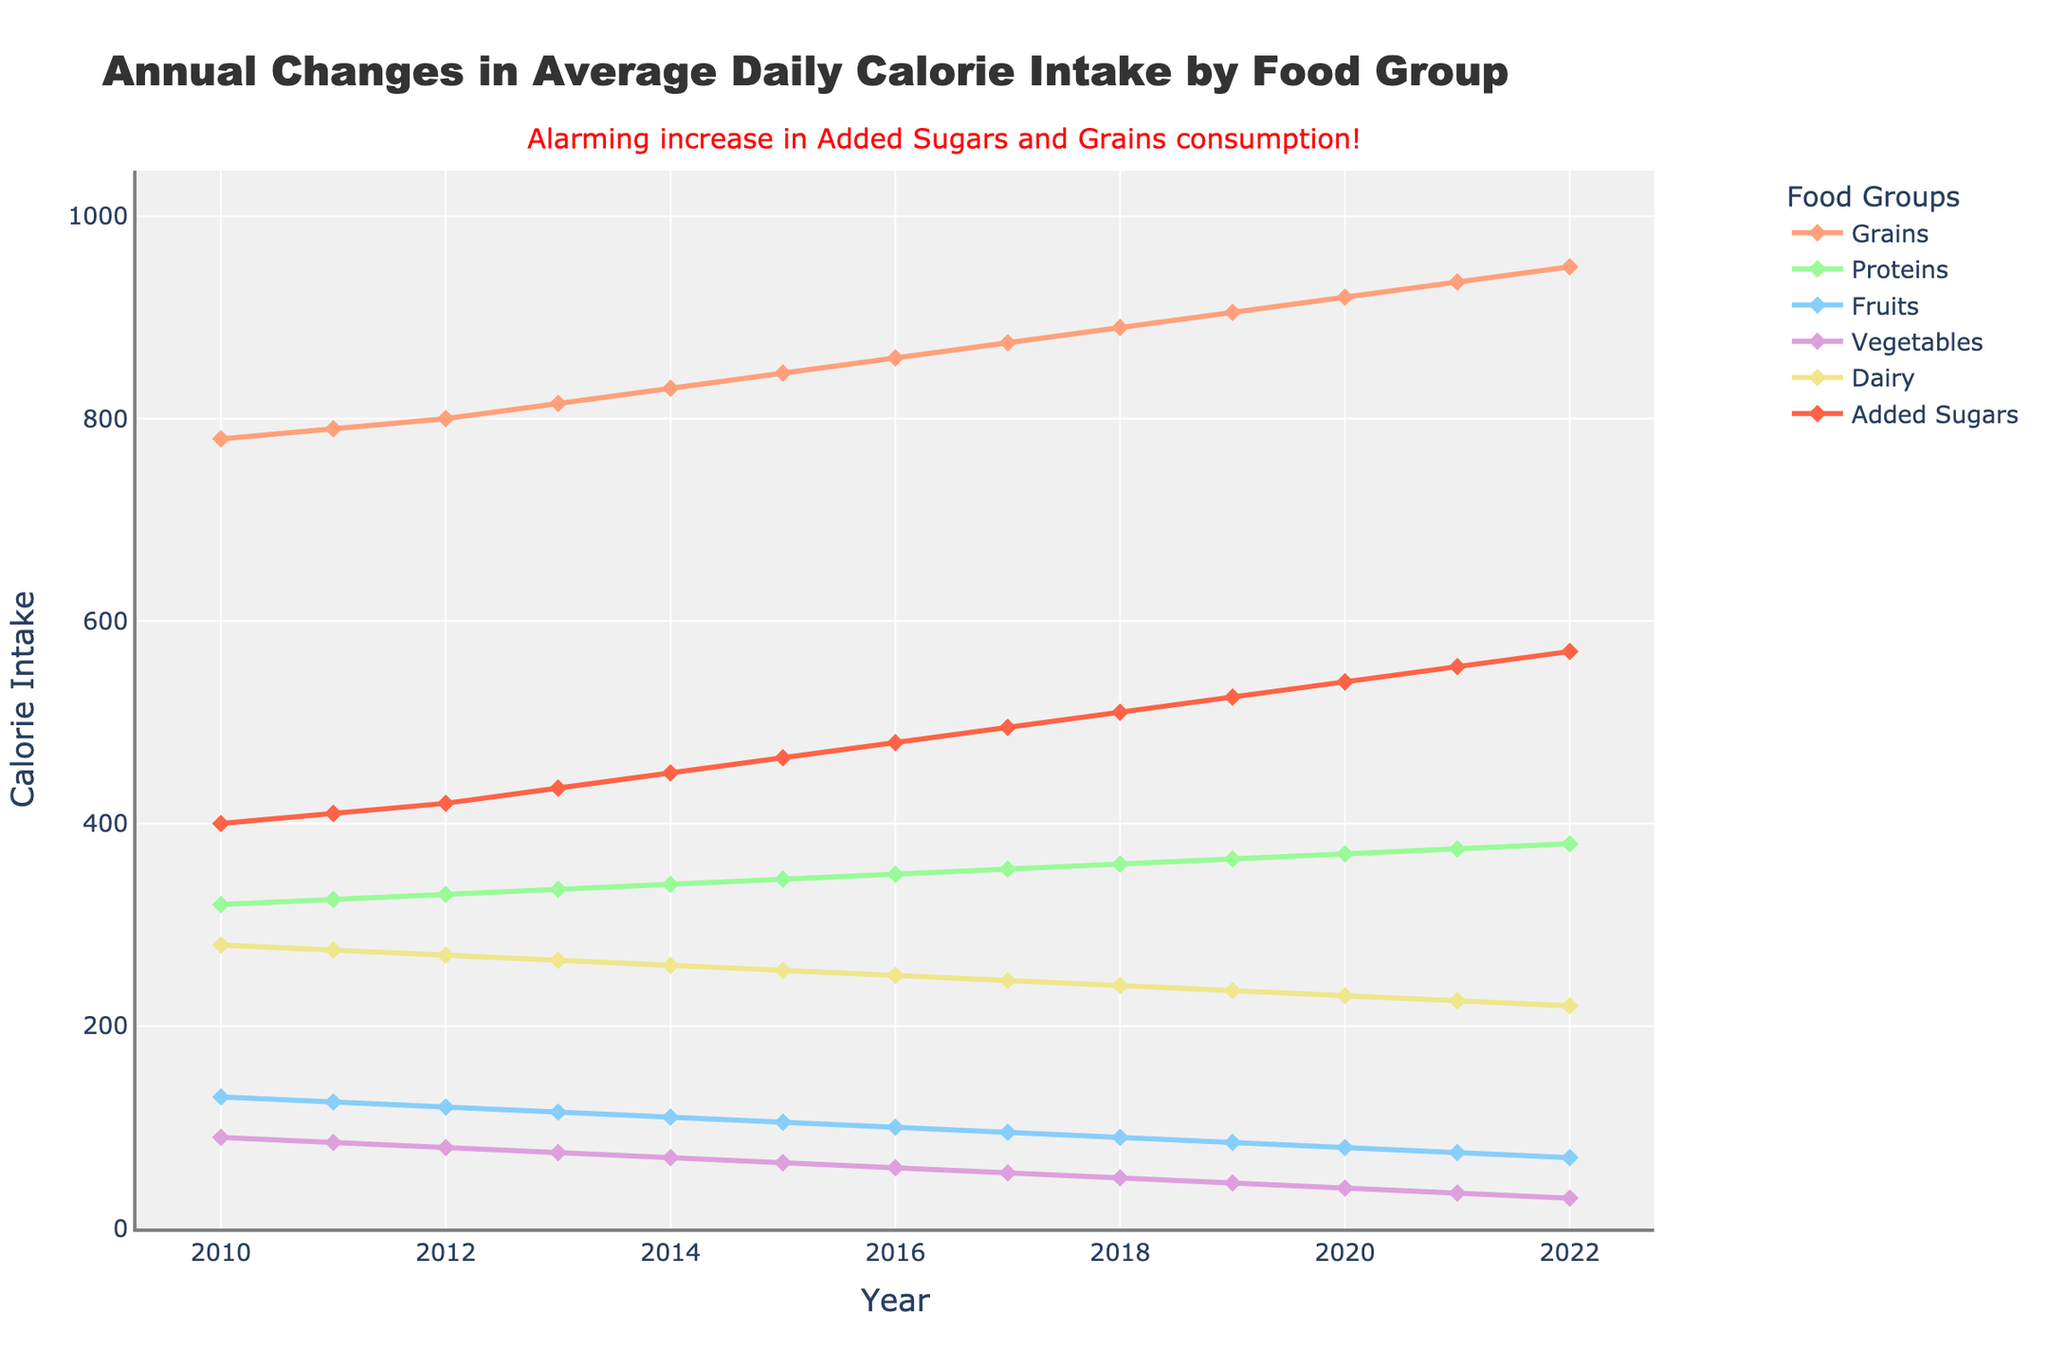What is the trend of added sugars in students' daily calorie intake from 2010 to 2022? Observe the line representing 'Added Sugars'. The line shows a consistent upward trend from 2010 to 2022 with calorie intake starting at 400 in 2010 and ending at 570 in 2022.
Answer: Increasing What was the average daily intake of grains in 2015? Refer to the data point for grains in the year 2015, which is 845 calories. This can be directly observed from the figure.
Answer: 845 calories Which food group had the highest increase in calorie intake over the years? Compare the starting and ending points of each food group to see the change over the years. 'Added Sugars' increased from 400 to 570, which is the highest increase among the groups.
Answer: Added Sugars How much did the average daily intake of vegetables decrease by from 2010 to 2022? Subtract the 2022 value (30 calories) from the 2010 value (90 calories) for vegetables. The decrease is 90 - 30 = 60 calories.
Answer: 60 calories Which two food groups had overlapping daily calorie intakes in any year? Look for lines that intersect over any year. The lines representing 'Proteins' and 'Added Sugars' intersect around the year 2021 when both had about 375 calories.
Answer: Proteins and Added Sugars How does the trend in protein intake compare to that of fruits? Observe the lines for 'Proteins' and 'Fruits'. Protein intake shows a consistent slight increase, while fruit intake shows a slight decrease over the years.
Answer: Protein intake is increasing while fruit intake is decreasing What is the percentage increase in grain calorie intake from 2010 to 2022? Calculate the percentage increase using ((950 - 780) / 780) * 100. This results in a (170 / 780) * 100 ≈ 21.79% increase.
Answer: Approximately 21.79% In which year did dairy calorie intake fall below 250 calories? Observe the line representing 'Dairy'. Dairy intake falls below 250 calories in 2018 and remains below that level afterward.
Answer: 2018 What is the difference between the highest and lowest calorie intake for fruits throughout the years? Identify the highest value (130 in 2010) and the lowest value (70 in 2022) for fruits. Calculate the difference, which is 130 - 70 = 60 calories.
Answer: 60 calories In which year was the combined intake of fruits and vegetables the lowest? Sum the values of 'Fruits' and 'Vegetables' for each year and find the year with the lowest sum. The lowest combined intake occurs in 2022 with (70 + 30) = 100 calories.
Answer: 2022 